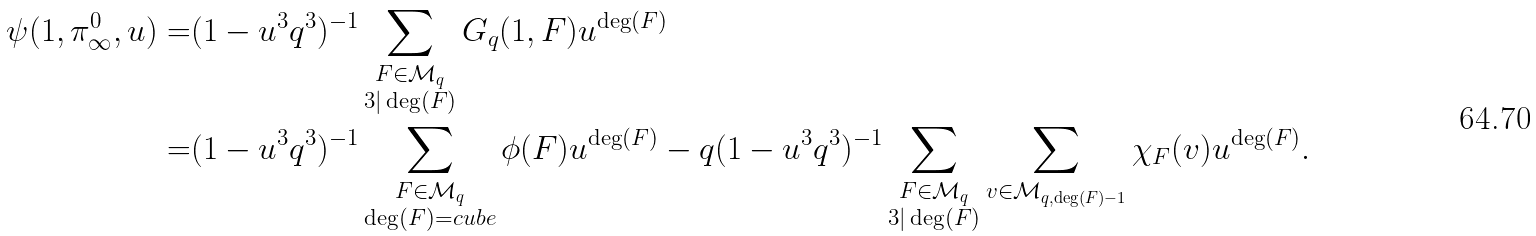<formula> <loc_0><loc_0><loc_500><loc_500>\psi ( 1 , \pi _ { \infty } ^ { 0 } , u ) = & ( 1 - u ^ { 3 } q ^ { 3 } ) ^ { - 1 } \sum _ { \substack { F \in \mathcal { M } _ { q } \\ 3 | \deg ( F ) } } G _ { q } ( 1 , F ) u ^ { \deg ( F ) } \\ = & ( 1 - u ^ { 3 } q ^ { 3 } ) ^ { - 1 } \sum _ { \substack { F \in \mathcal { M } _ { q } \\ \deg ( F ) = c u b e } } \phi ( F ) u ^ { \deg ( F ) } - q ( 1 - u ^ { 3 } q ^ { 3 } ) ^ { - 1 } \sum _ { \substack { F \in \mathcal { M } _ { q } \\ 3 | \deg ( F ) } } \sum _ { v \in \mathcal { M } _ { q , \deg ( F ) - 1 } } \chi _ { F } ( v ) u ^ { \deg ( F ) } . \\</formula> 